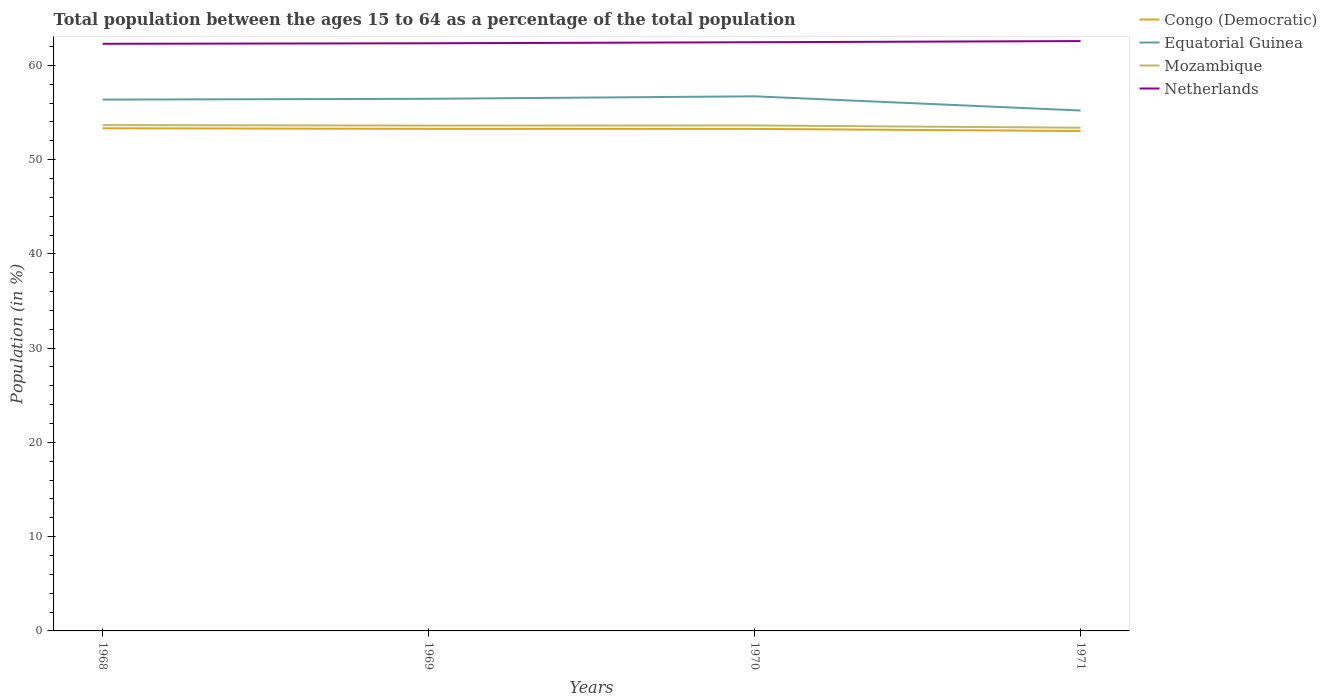Across all years, what is the maximum percentage of the population ages 15 to 64 in Equatorial Guinea?
Offer a terse response. 55.21. In which year was the percentage of the population ages 15 to 64 in Netherlands maximum?
Make the answer very short. 1968. What is the total percentage of the population ages 15 to 64 in Netherlands in the graph?
Offer a terse response. -0.12. What is the difference between the highest and the second highest percentage of the population ages 15 to 64 in Netherlands?
Provide a short and direct response. 0.29. What is the difference between the highest and the lowest percentage of the population ages 15 to 64 in Netherlands?
Keep it short and to the point. 2. How many lines are there?
Give a very brief answer. 4. How many years are there in the graph?
Offer a very short reply. 4. Are the values on the major ticks of Y-axis written in scientific E-notation?
Ensure brevity in your answer.  No. Does the graph contain any zero values?
Offer a very short reply. No. Does the graph contain grids?
Provide a succinct answer. No. Where does the legend appear in the graph?
Give a very brief answer. Top right. What is the title of the graph?
Offer a terse response. Total population between the ages 15 to 64 as a percentage of the total population. Does "Guinea-Bissau" appear as one of the legend labels in the graph?
Your answer should be very brief. No. What is the label or title of the Y-axis?
Offer a terse response. Population (in %). What is the Population (in %) of Congo (Democratic) in 1968?
Your answer should be compact. 53.33. What is the Population (in %) of Equatorial Guinea in 1968?
Offer a terse response. 56.37. What is the Population (in %) in Mozambique in 1968?
Give a very brief answer. 53.66. What is the Population (in %) of Netherlands in 1968?
Your response must be concise. 62.29. What is the Population (in %) in Congo (Democratic) in 1969?
Offer a very short reply. 53.27. What is the Population (in %) in Equatorial Guinea in 1969?
Your answer should be compact. 56.45. What is the Population (in %) of Mozambique in 1969?
Make the answer very short. 53.61. What is the Population (in %) of Netherlands in 1969?
Offer a very short reply. 62.34. What is the Population (in %) in Congo (Democratic) in 1970?
Provide a short and direct response. 53.26. What is the Population (in %) in Equatorial Guinea in 1970?
Your response must be concise. 56.72. What is the Population (in %) of Mozambique in 1970?
Keep it short and to the point. 53.62. What is the Population (in %) in Netherlands in 1970?
Offer a terse response. 62.45. What is the Population (in %) in Congo (Democratic) in 1971?
Provide a short and direct response. 53.04. What is the Population (in %) of Equatorial Guinea in 1971?
Offer a terse response. 55.21. What is the Population (in %) of Mozambique in 1971?
Provide a succinct answer. 53.39. What is the Population (in %) of Netherlands in 1971?
Your answer should be very brief. 62.58. Across all years, what is the maximum Population (in %) in Congo (Democratic)?
Your answer should be very brief. 53.33. Across all years, what is the maximum Population (in %) of Equatorial Guinea?
Provide a succinct answer. 56.72. Across all years, what is the maximum Population (in %) of Mozambique?
Offer a very short reply. 53.66. Across all years, what is the maximum Population (in %) of Netherlands?
Offer a terse response. 62.58. Across all years, what is the minimum Population (in %) of Congo (Democratic)?
Your response must be concise. 53.04. Across all years, what is the minimum Population (in %) of Equatorial Guinea?
Give a very brief answer. 55.21. Across all years, what is the minimum Population (in %) of Mozambique?
Ensure brevity in your answer.  53.39. Across all years, what is the minimum Population (in %) in Netherlands?
Give a very brief answer. 62.29. What is the total Population (in %) of Congo (Democratic) in the graph?
Your response must be concise. 212.89. What is the total Population (in %) of Equatorial Guinea in the graph?
Your answer should be compact. 224.75. What is the total Population (in %) in Mozambique in the graph?
Give a very brief answer. 214.29. What is the total Population (in %) of Netherlands in the graph?
Provide a short and direct response. 249.67. What is the difference between the Population (in %) in Congo (Democratic) in 1968 and that in 1969?
Offer a very short reply. 0.06. What is the difference between the Population (in %) in Equatorial Guinea in 1968 and that in 1969?
Make the answer very short. -0.09. What is the difference between the Population (in %) of Mozambique in 1968 and that in 1969?
Provide a succinct answer. 0.05. What is the difference between the Population (in %) in Netherlands in 1968 and that in 1969?
Give a very brief answer. -0.06. What is the difference between the Population (in %) in Congo (Democratic) in 1968 and that in 1970?
Provide a short and direct response. 0.07. What is the difference between the Population (in %) of Equatorial Guinea in 1968 and that in 1970?
Provide a succinct answer. -0.35. What is the difference between the Population (in %) in Mozambique in 1968 and that in 1970?
Your answer should be very brief. 0.04. What is the difference between the Population (in %) in Netherlands in 1968 and that in 1970?
Provide a succinct answer. -0.17. What is the difference between the Population (in %) in Congo (Democratic) in 1968 and that in 1971?
Offer a terse response. 0.29. What is the difference between the Population (in %) in Equatorial Guinea in 1968 and that in 1971?
Make the answer very short. 1.16. What is the difference between the Population (in %) in Mozambique in 1968 and that in 1971?
Provide a short and direct response. 0.28. What is the difference between the Population (in %) of Netherlands in 1968 and that in 1971?
Offer a terse response. -0.29. What is the difference between the Population (in %) of Congo (Democratic) in 1969 and that in 1970?
Your response must be concise. 0.01. What is the difference between the Population (in %) of Equatorial Guinea in 1969 and that in 1970?
Your answer should be compact. -0.26. What is the difference between the Population (in %) of Mozambique in 1969 and that in 1970?
Offer a very short reply. -0.01. What is the difference between the Population (in %) in Netherlands in 1969 and that in 1970?
Ensure brevity in your answer.  -0.11. What is the difference between the Population (in %) of Congo (Democratic) in 1969 and that in 1971?
Make the answer very short. 0.23. What is the difference between the Population (in %) in Equatorial Guinea in 1969 and that in 1971?
Ensure brevity in your answer.  1.24. What is the difference between the Population (in %) in Mozambique in 1969 and that in 1971?
Give a very brief answer. 0.23. What is the difference between the Population (in %) of Netherlands in 1969 and that in 1971?
Offer a very short reply. -0.23. What is the difference between the Population (in %) in Congo (Democratic) in 1970 and that in 1971?
Give a very brief answer. 0.22. What is the difference between the Population (in %) in Equatorial Guinea in 1970 and that in 1971?
Your answer should be compact. 1.51. What is the difference between the Population (in %) in Mozambique in 1970 and that in 1971?
Make the answer very short. 0.24. What is the difference between the Population (in %) in Netherlands in 1970 and that in 1971?
Offer a terse response. -0.12. What is the difference between the Population (in %) of Congo (Democratic) in 1968 and the Population (in %) of Equatorial Guinea in 1969?
Keep it short and to the point. -3.13. What is the difference between the Population (in %) in Congo (Democratic) in 1968 and the Population (in %) in Mozambique in 1969?
Provide a succinct answer. -0.29. What is the difference between the Population (in %) of Congo (Democratic) in 1968 and the Population (in %) of Netherlands in 1969?
Your answer should be very brief. -9.02. What is the difference between the Population (in %) of Equatorial Guinea in 1968 and the Population (in %) of Mozambique in 1969?
Make the answer very short. 2.75. What is the difference between the Population (in %) in Equatorial Guinea in 1968 and the Population (in %) in Netherlands in 1969?
Your answer should be compact. -5.98. What is the difference between the Population (in %) in Mozambique in 1968 and the Population (in %) in Netherlands in 1969?
Provide a short and direct response. -8.68. What is the difference between the Population (in %) in Congo (Democratic) in 1968 and the Population (in %) in Equatorial Guinea in 1970?
Provide a succinct answer. -3.39. What is the difference between the Population (in %) in Congo (Democratic) in 1968 and the Population (in %) in Mozambique in 1970?
Your answer should be very brief. -0.3. What is the difference between the Population (in %) in Congo (Democratic) in 1968 and the Population (in %) in Netherlands in 1970?
Provide a succinct answer. -9.13. What is the difference between the Population (in %) of Equatorial Guinea in 1968 and the Population (in %) of Mozambique in 1970?
Offer a very short reply. 2.74. What is the difference between the Population (in %) in Equatorial Guinea in 1968 and the Population (in %) in Netherlands in 1970?
Your answer should be compact. -6.09. What is the difference between the Population (in %) of Mozambique in 1968 and the Population (in %) of Netherlands in 1970?
Provide a short and direct response. -8.79. What is the difference between the Population (in %) of Congo (Democratic) in 1968 and the Population (in %) of Equatorial Guinea in 1971?
Give a very brief answer. -1.88. What is the difference between the Population (in %) of Congo (Democratic) in 1968 and the Population (in %) of Mozambique in 1971?
Your response must be concise. -0.06. What is the difference between the Population (in %) of Congo (Democratic) in 1968 and the Population (in %) of Netherlands in 1971?
Your answer should be very brief. -9.25. What is the difference between the Population (in %) of Equatorial Guinea in 1968 and the Population (in %) of Mozambique in 1971?
Provide a short and direct response. 2.98. What is the difference between the Population (in %) of Equatorial Guinea in 1968 and the Population (in %) of Netherlands in 1971?
Your response must be concise. -6.21. What is the difference between the Population (in %) of Mozambique in 1968 and the Population (in %) of Netherlands in 1971?
Your response must be concise. -8.92. What is the difference between the Population (in %) in Congo (Democratic) in 1969 and the Population (in %) in Equatorial Guinea in 1970?
Offer a terse response. -3.45. What is the difference between the Population (in %) of Congo (Democratic) in 1969 and the Population (in %) of Mozambique in 1970?
Give a very brief answer. -0.36. What is the difference between the Population (in %) of Congo (Democratic) in 1969 and the Population (in %) of Netherlands in 1970?
Provide a succinct answer. -9.19. What is the difference between the Population (in %) in Equatorial Guinea in 1969 and the Population (in %) in Mozambique in 1970?
Make the answer very short. 2.83. What is the difference between the Population (in %) in Equatorial Guinea in 1969 and the Population (in %) in Netherlands in 1970?
Give a very brief answer. -6. What is the difference between the Population (in %) in Mozambique in 1969 and the Population (in %) in Netherlands in 1970?
Give a very brief answer. -8.84. What is the difference between the Population (in %) of Congo (Democratic) in 1969 and the Population (in %) of Equatorial Guinea in 1971?
Your answer should be compact. -1.94. What is the difference between the Population (in %) in Congo (Democratic) in 1969 and the Population (in %) in Mozambique in 1971?
Make the answer very short. -0.12. What is the difference between the Population (in %) in Congo (Democratic) in 1969 and the Population (in %) in Netherlands in 1971?
Your answer should be very brief. -9.31. What is the difference between the Population (in %) of Equatorial Guinea in 1969 and the Population (in %) of Mozambique in 1971?
Provide a succinct answer. 3.07. What is the difference between the Population (in %) of Equatorial Guinea in 1969 and the Population (in %) of Netherlands in 1971?
Make the answer very short. -6.12. What is the difference between the Population (in %) of Mozambique in 1969 and the Population (in %) of Netherlands in 1971?
Make the answer very short. -8.96. What is the difference between the Population (in %) of Congo (Democratic) in 1970 and the Population (in %) of Equatorial Guinea in 1971?
Give a very brief answer. -1.95. What is the difference between the Population (in %) of Congo (Democratic) in 1970 and the Population (in %) of Mozambique in 1971?
Provide a succinct answer. -0.13. What is the difference between the Population (in %) of Congo (Democratic) in 1970 and the Population (in %) of Netherlands in 1971?
Offer a very short reply. -9.32. What is the difference between the Population (in %) of Equatorial Guinea in 1970 and the Population (in %) of Mozambique in 1971?
Provide a short and direct response. 3.33. What is the difference between the Population (in %) of Equatorial Guinea in 1970 and the Population (in %) of Netherlands in 1971?
Offer a very short reply. -5.86. What is the difference between the Population (in %) in Mozambique in 1970 and the Population (in %) in Netherlands in 1971?
Offer a terse response. -8.95. What is the average Population (in %) of Congo (Democratic) per year?
Keep it short and to the point. 53.22. What is the average Population (in %) of Equatorial Guinea per year?
Offer a terse response. 56.19. What is the average Population (in %) of Mozambique per year?
Your response must be concise. 53.57. What is the average Population (in %) of Netherlands per year?
Your answer should be very brief. 62.42. In the year 1968, what is the difference between the Population (in %) of Congo (Democratic) and Population (in %) of Equatorial Guinea?
Provide a succinct answer. -3.04. In the year 1968, what is the difference between the Population (in %) in Congo (Democratic) and Population (in %) in Mozambique?
Provide a short and direct response. -0.33. In the year 1968, what is the difference between the Population (in %) of Congo (Democratic) and Population (in %) of Netherlands?
Your response must be concise. -8.96. In the year 1968, what is the difference between the Population (in %) of Equatorial Guinea and Population (in %) of Mozambique?
Make the answer very short. 2.71. In the year 1968, what is the difference between the Population (in %) of Equatorial Guinea and Population (in %) of Netherlands?
Keep it short and to the point. -5.92. In the year 1968, what is the difference between the Population (in %) of Mozambique and Population (in %) of Netherlands?
Your answer should be very brief. -8.63. In the year 1969, what is the difference between the Population (in %) in Congo (Democratic) and Population (in %) in Equatorial Guinea?
Your response must be concise. -3.19. In the year 1969, what is the difference between the Population (in %) in Congo (Democratic) and Population (in %) in Mozambique?
Your answer should be very brief. -0.35. In the year 1969, what is the difference between the Population (in %) in Congo (Democratic) and Population (in %) in Netherlands?
Make the answer very short. -9.08. In the year 1969, what is the difference between the Population (in %) in Equatorial Guinea and Population (in %) in Mozambique?
Provide a short and direct response. 2.84. In the year 1969, what is the difference between the Population (in %) of Equatorial Guinea and Population (in %) of Netherlands?
Give a very brief answer. -5.89. In the year 1969, what is the difference between the Population (in %) in Mozambique and Population (in %) in Netherlands?
Make the answer very short. -8.73. In the year 1970, what is the difference between the Population (in %) in Congo (Democratic) and Population (in %) in Equatorial Guinea?
Make the answer very short. -3.46. In the year 1970, what is the difference between the Population (in %) of Congo (Democratic) and Population (in %) of Mozambique?
Provide a succinct answer. -0.37. In the year 1970, what is the difference between the Population (in %) in Congo (Democratic) and Population (in %) in Netherlands?
Give a very brief answer. -9.2. In the year 1970, what is the difference between the Population (in %) in Equatorial Guinea and Population (in %) in Mozambique?
Give a very brief answer. 3.09. In the year 1970, what is the difference between the Population (in %) in Equatorial Guinea and Population (in %) in Netherlands?
Your response must be concise. -5.74. In the year 1970, what is the difference between the Population (in %) of Mozambique and Population (in %) of Netherlands?
Your response must be concise. -8.83. In the year 1971, what is the difference between the Population (in %) in Congo (Democratic) and Population (in %) in Equatorial Guinea?
Your answer should be compact. -2.17. In the year 1971, what is the difference between the Population (in %) in Congo (Democratic) and Population (in %) in Mozambique?
Your answer should be compact. -0.35. In the year 1971, what is the difference between the Population (in %) of Congo (Democratic) and Population (in %) of Netherlands?
Ensure brevity in your answer.  -9.54. In the year 1971, what is the difference between the Population (in %) of Equatorial Guinea and Population (in %) of Mozambique?
Your answer should be compact. 1.82. In the year 1971, what is the difference between the Population (in %) in Equatorial Guinea and Population (in %) in Netherlands?
Give a very brief answer. -7.37. In the year 1971, what is the difference between the Population (in %) of Mozambique and Population (in %) of Netherlands?
Ensure brevity in your answer.  -9.19. What is the ratio of the Population (in %) of Equatorial Guinea in 1968 to that in 1969?
Provide a succinct answer. 1. What is the ratio of the Population (in %) in Mozambique in 1968 to that in 1969?
Make the answer very short. 1. What is the ratio of the Population (in %) in Netherlands in 1968 to that in 1969?
Offer a very short reply. 1. What is the ratio of the Population (in %) of Congo (Democratic) in 1968 to that in 1970?
Offer a terse response. 1. What is the ratio of the Population (in %) of Mozambique in 1968 to that in 1970?
Provide a short and direct response. 1. What is the ratio of the Population (in %) of Netherlands in 1968 to that in 1970?
Keep it short and to the point. 1. What is the ratio of the Population (in %) of Congo (Democratic) in 1968 to that in 1971?
Offer a terse response. 1.01. What is the ratio of the Population (in %) of Equatorial Guinea in 1968 to that in 1971?
Your answer should be compact. 1.02. What is the ratio of the Population (in %) of Mozambique in 1968 to that in 1971?
Keep it short and to the point. 1.01. What is the ratio of the Population (in %) of Netherlands in 1968 to that in 1971?
Keep it short and to the point. 1. What is the ratio of the Population (in %) of Mozambique in 1969 to that in 1970?
Make the answer very short. 1. What is the ratio of the Population (in %) in Congo (Democratic) in 1969 to that in 1971?
Offer a terse response. 1. What is the ratio of the Population (in %) in Equatorial Guinea in 1969 to that in 1971?
Keep it short and to the point. 1.02. What is the ratio of the Population (in %) of Netherlands in 1969 to that in 1971?
Your response must be concise. 1. What is the ratio of the Population (in %) in Equatorial Guinea in 1970 to that in 1971?
Provide a succinct answer. 1.03. What is the ratio of the Population (in %) in Netherlands in 1970 to that in 1971?
Your answer should be very brief. 1. What is the difference between the highest and the second highest Population (in %) in Congo (Democratic)?
Offer a very short reply. 0.06. What is the difference between the highest and the second highest Population (in %) of Equatorial Guinea?
Ensure brevity in your answer.  0.26. What is the difference between the highest and the second highest Population (in %) of Mozambique?
Offer a very short reply. 0.04. What is the difference between the highest and the second highest Population (in %) in Netherlands?
Make the answer very short. 0.12. What is the difference between the highest and the lowest Population (in %) in Congo (Democratic)?
Keep it short and to the point. 0.29. What is the difference between the highest and the lowest Population (in %) in Equatorial Guinea?
Ensure brevity in your answer.  1.51. What is the difference between the highest and the lowest Population (in %) in Mozambique?
Give a very brief answer. 0.28. What is the difference between the highest and the lowest Population (in %) in Netherlands?
Your answer should be very brief. 0.29. 